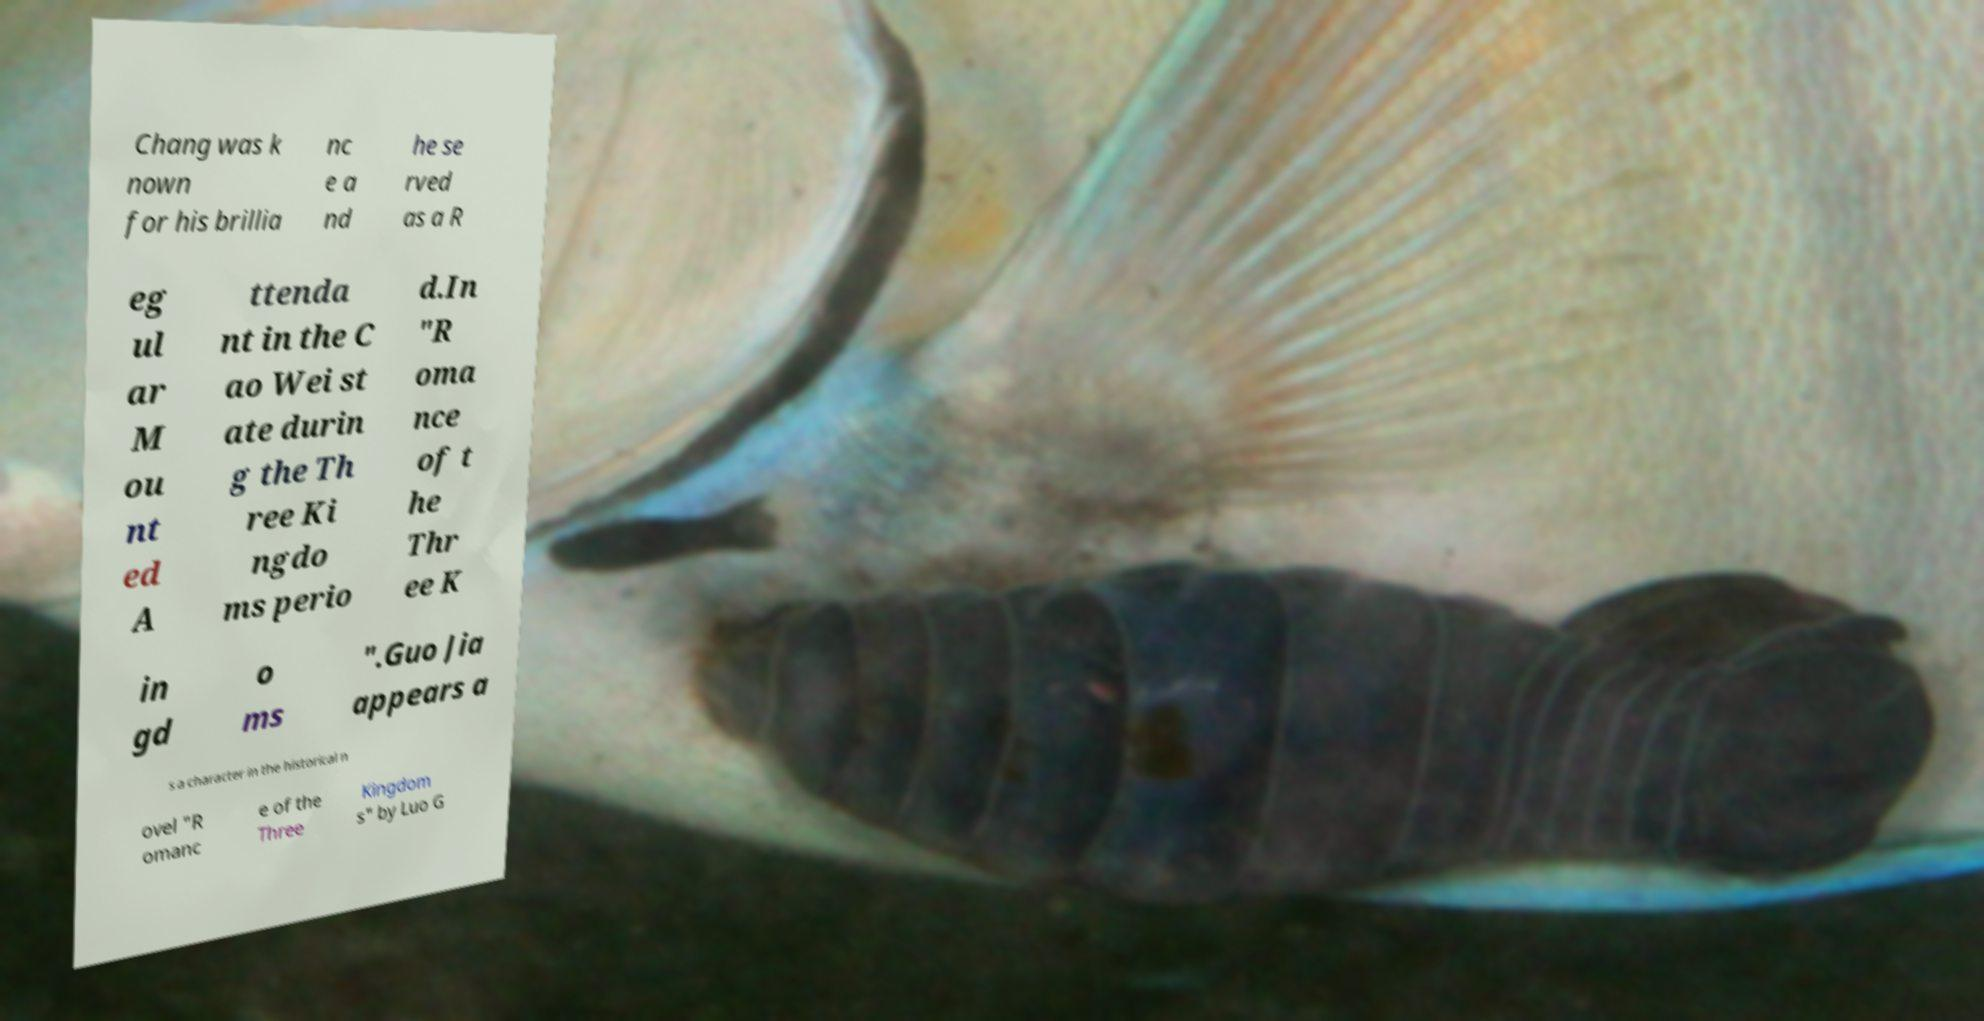Could you assist in decoding the text presented in this image and type it out clearly? Chang was k nown for his brillia nc e a nd he se rved as a R eg ul ar M ou nt ed A ttenda nt in the C ao Wei st ate durin g the Th ree Ki ngdo ms perio d.In "R oma nce of t he Thr ee K in gd o ms ".Guo Jia appears a s a character in the historical n ovel "R omanc e of the Three Kingdom s" by Luo G 